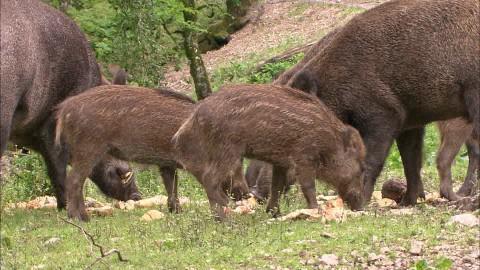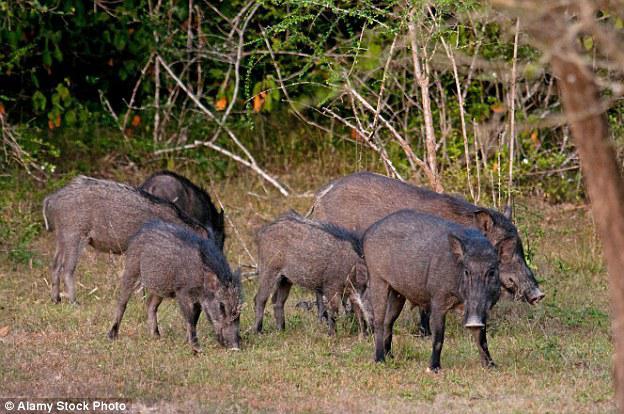The first image is the image on the left, the second image is the image on the right. Examine the images to the left and right. Is the description "There are at most 5 total warthogs." accurate? Answer yes or no. No. The first image is the image on the left, the second image is the image on the right. Analyze the images presented: Is the assertion "An image contains no more than two warthogs, which face forward." valid? Answer yes or no. No. 